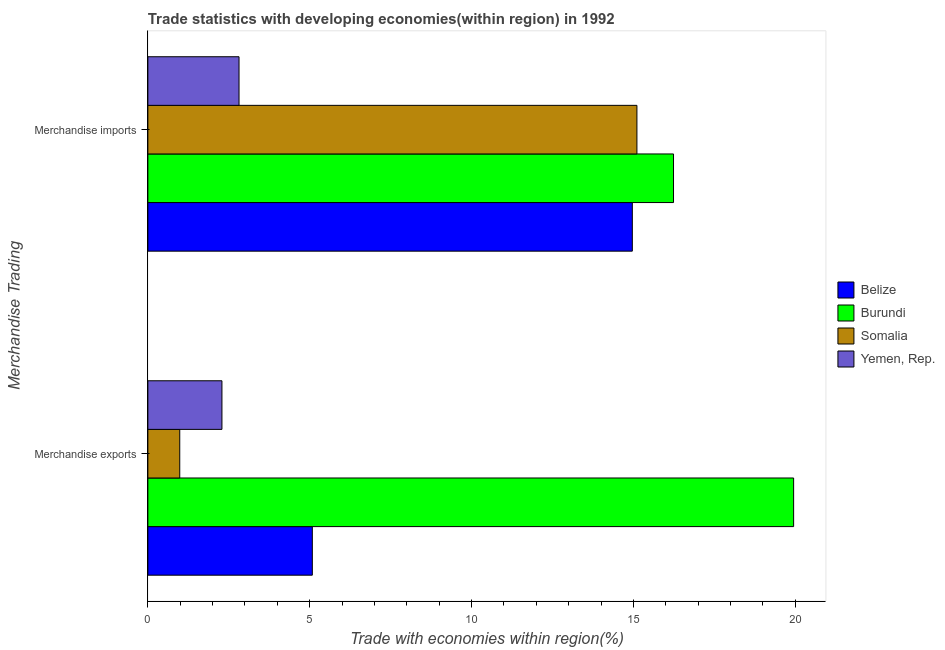How many different coloured bars are there?
Ensure brevity in your answer.  4. How many groups of bars are there?
Give a very brief answer. 2. Are the number of bars on each tick of the Y-axis equal?
Keep it short and to the point. Yes. How many bars are there on the 2nd tick from the top?
Offer a terse response. 4. How many bars are there on the 1st tick from the bottom?
Your response must be concise. 4. What is the label of the 1st group of bars from the top?
Your response must be concise. Merchandise imports. What is the merchandise imports in Somalia?
Make the answer very short. 15.11. Across all countries, what is the maximum merchandise exports?
Your response must be concise. 19.95. Across all countries, what is the minimum merchandise imports?
Keep it short and to the point. 2.82. In which country was the merchandise imports maximum?
Your response must be concise. Burundi. In which country was the merchandise exports minimum?
Provide a short and direct response. Somalia. What is the total merchandise imports in the graph?
Your answer should be compact. 49.13. What is the difference between the merchandise exports in Burundi and that in Yemen, Rep.?
Offer a terse response. 17.66. What is the difference between the merchandise imports in Somalia and the merchandise exports in Yemen, Rep.?
Provide a short and direct response. 12.82. What is the average merchandise imports per country?
Your answer should be compact. 12.28. What is the difference between the merchandise exports and merchandise imports in Yemen, Rep.?
Offer a very short reply. -0.53. In how many countries, is the merchandise exports greater than 13 %?
Give a very brief answer. 1. What is the ratio of the merchandise imports in Belize to that in Burundi?
Your answer should be compact. 0.92. Is the merchandise exports in Yemen, Rep. less than that in Somalia?
Your answer should be very brief. No. What does the 4th bar from the top in Merchandise exports represents?
Provide a succinct answer. Belize. What does the 2nd bar from the bottom in Merchandise exports represents?
Offer a very short reply. Burundi. How many bars are there?
Make the answer very short. 8. What is the difference between two consecutive major ticks on the X-axis?
Offer a terse response. 5. Does the graph contain any zero values?
Offer a terse response. No. Where does the legend appear in the graph?
Offer a very short reply. Center right. How many legend labels are there?
Your response must be concise. 4. How are the legend labels stacked?
Ensure brevity in your answer.  Vertical. What is the title of the graph?
Make the answer very short. Trade statistics with developing economies(within region) in 1992. Does "Congo (Republic)" appear as one of the legend labels in the graph?
Provide a short and direct response. No. What is the label or title of the X-axis?
Keep it short and to the point. Trade with economies within region(%). What is the label or title of the Y-axis?
Offer a very short reply. Merchandise Trading. What is the Trade with economies within region(%) in Belize in Merchandise exports?
Your response must be concise. 5.08. What is the Trade with economies within region(%) in Burundi in Merchandise exports?
Give a very brief answer. 19.95. What is the Trade with economies within region(%) of Somalia in Merchandise exports?
Your response must be concise. 0.98. What is the Trade with economies within region(%) of Yemen, Rep. in Merchandise exports?
Provide a short and direct response. 2.29. What is the Trade with economies within region(%) in Belize in Merchandise imports?
Make the answer very short. 14.97. What is the Trade with economies within region(%) of Burundi in Merchandise imports?
Offer a terse response. 16.24. What is the Trade with economies within region(%) of Somalia in Merchandise imports?
Ensure brevity in your answer.  15.11. What is the Trade with economies within region(%) of Yemen, Rep. in Merchandise imports?
Offer a terse response. 2.82. Across all Merchandise Trading, what is the maximum Trade with economies within region(%) in Belize?
Your response must be concise. 14.97. Across all Merchandise Trading, what is the maximum Trade with economies within region(%) of Burundi?
Offer a very short reply. 19.95. Across all Merchandise Trading, what is the maximum Trade with economies within region(%) of Somalia?
Provide a succinct answer. 15.11. Across all Merchandise Trading, what is the maximum Trade with economies within region(%) in Yemen, Rep.?
Give a very brief answer. 2.82. Across all Merchandise Trading, what is the minimum Trade with economies within region(%) in Belize?
Keep it short and to the point. 5.08. Across all Merchandise Trading, what is the minimum Trade with economies within region(%) in Burundi?
Ensure brevity in your answer.  16.24. Across all Merchandise Trading, what is the minimum Trade with economies within region(%) of Somalia?
Provide a short and direct response. 0.98. Across all Merchandise Trading, what is the minimum Trade with economies within region(%) in Yemen, Rep.?
Offer a terse response. 2.29. What is the total Trade with economies within region(%) in Belize in the graph?
Make the answer very short. 20.05. What is the total Trade with economies within region(%) in Burundi in the graph?
Keep it short and to the point. 36.19. What is the total Trade with economies within region(%) in Somalia in the graph?
Provide a short and direct response. 16.09. What is the total Trade with economies within region(%) of Yemen, Rep. in the graph?
Your response must be concise. 5.1. What is the difference between the Trade with economies within region(%) of Belize in Merchandise exports and that in Merchandise imports?
Give a very brief answer. -9.89. What is the difference between the Trade with economies within region(%) in Burundi in Merchandise exports and that in Merchandise imports?
Your response must be concise. 3.71. What is the difference between the Trade with economies within region(%) of Somalia in Merchandise exports and that in Merchandise imports?
Keep it short and to the point. -14.12. What is the difference between the Trade with economies within region(%) in Yemen, Rep. in Merchandise exports and that in Merchandise imports?
Your answer should be compact. -0.53. What is the difference between the Trade with economies within region(%) in Belize in Merchandise exports and the Trade with economies within region(%) in Burundi in Merchandise imports?
Offer a terse response. -11.16. What is the difference between the Trade with economies within region(%) in Belize in Merchandise exports and the Trade with economies within region(%) in Somalia in Merchandise imports?
Provide a short and direct response. -10.03. What is the difference between the Trade with economies within region(%) of Belize in Merchandise exports and the Trade with economies within region(%) of Yemen, Rep. in Merchandise imports?
Your answer should be very brief. 2.26. What is the difference between the Trade with economies within region(%) of Burundi in Merchandise exports and the Trade with economies within region(%) of Somalia in Merchandise imports?
Offer a terse response. 4.84. What is the difference between the Trade with economies within region(%) in Burundi in Merchandise exports and the Trade with economies within region(%) in Yemen, Rep. in Merchandise imports?
Provide a succinct answer. 17.13. What is the difference between the Trade with economies within region(%) in Somalia in Merchandise exports and the Trade with economies within region(%) in Yemen, Rep. in Merchandise imports?
Make the answer very short. -1.83. What is the average Trade with economies within region(%) in Belize per Merchandise Trading?
Keep it short and to the point. 10.02. What is the average Trade with economies within region(%) of Burundi per Merchandise Trading?
Give a very brief answer. 18.09. What is the average Trade with economies within region(%) in Somalia per Merchandise Trading?
Provide a short and direct response. 8.05. What is the average Trade with economies within region(%) in Yemen, Rep. per Merchandise Trading?
Provide a short and direct response. 2.55. What is the difference between the Trade with economies within region(%) of Belize and Trade with economies within region(%) of Burundi in Merchandise exports?
Provide a succinct answer. -14.87. What is the difference between the Trade with economies within region(%) in Belize and Trade with economies within region(%) in Somalia in Merchandise exports?
Give a very brief answer. 4.1. What is the difference between the Trade with economies within region(%) in Belize and Trade with economies within region(%) in Yemen, Rep. in Merchandise exports?
Provide a succinct answer. 2.79. What is the difference between the Trade with economies within region(%) of Burundi and Trade with economies within region(%) of Somalia in Merchandise exports?
Provide a short and direct response. 18.96. What is the difference between the Trade with economies within region(%) of Burundi and Trade with economies within region(%) of Yemen, Rep. in Merchandise exports?
Give a very brief answer. 17.66. What is the difference between the Trade with economies within region(%) of Somalia and Trade with economies within region(%) of Yemen, Rep. in Merchandise exports?
Your answer should be compact. -1.3. What is the difference between the Trade with economies within region(%) of Belize and Trade with economies within region(%) of Burundi in Merchandise imports?
Provide a short and direct response. -1.27. What is the difference between the Trade with economies within region(%) in Belize and Trade with economies within region(%) in Somalia in Merchandise imports?
Offer a very short reply. -0.14. What is the difference between the Trade with economies within region(%) of Belize and Trade with economies within region(%) of Yemen, Rep. in Merchandise imports?
Keep it short and to the point. 12.15. What is the difference between the Trade with economies within region(%) in Burundi and Trade with economies within region(%) in Somalia in Merchandise imports?
Provide a succinct answer. 1.13. What is the difference between the Trade with economies within region(%) in Burundi and Trade with economies within region(%) in Yemen, Rep. in Merchandise imports?
Offer a terse response. 13.42. What is the difference between the Trade with economies within region(%) in Somalia and Trade with economies within region(%) in Yemen, Rep. in Merchandise imports?
Provide a short and direct response. 12.29. What is the ratio of the Trade with economies within region(%) of Belize in Merchandise exports to that in Merchandise imports?
Keep it short and to the point. 0.34. What is the ratio of the Trade with economies within region(%) in Burundi in Merchandise exports to that in Merchandise imports?
Provide a short and direct response. 1.23. What is the ratio of the Trade with economies within region(%) of Somalia in Merchandise exports to that in Merchandise imports?
Keep it short and to the point. 0.07. What is the ratio of the Trade with economies within region(%) in Yemen, Rep. in Merchandise exports to that in Merchandise imports?
Offer a terse response. 0.81. What is the difference between the highest and the second highest Trade with economies within region(%) in Belize?
Provide a succinct answer. 9.89. What is the difference between the highest and the second highest Trade with economies within region(%) of Burundi?
Provide a succinct answer. 3.71. What is the difference between the highest and the second highest Trade with economies within region(%) of Somalia?
Provide a short and direct response. 14.12. What is the difference between the highest and the second highest Trade with economies within region(%) in Yemen, Rep.?
Offer a terse response. 0.53. What is the difference between the highest and the lowest Trade with economies within region(%) in Belize?
Ensure brevity in your answer.  9.89. What is the difference between the highest and the lowest Trade with economies within region(%) in Burundi?
Make the answer very short. 3.71. What is the difference between the highest and the lowest Trade with economies within region(%) in Somalia?
Your answer should be compact. 14.12. What is the difference between the highest and the lowest Trade with economies within region(%) in Yemen, Rep.?
Give a very brief answer. 0.53. 